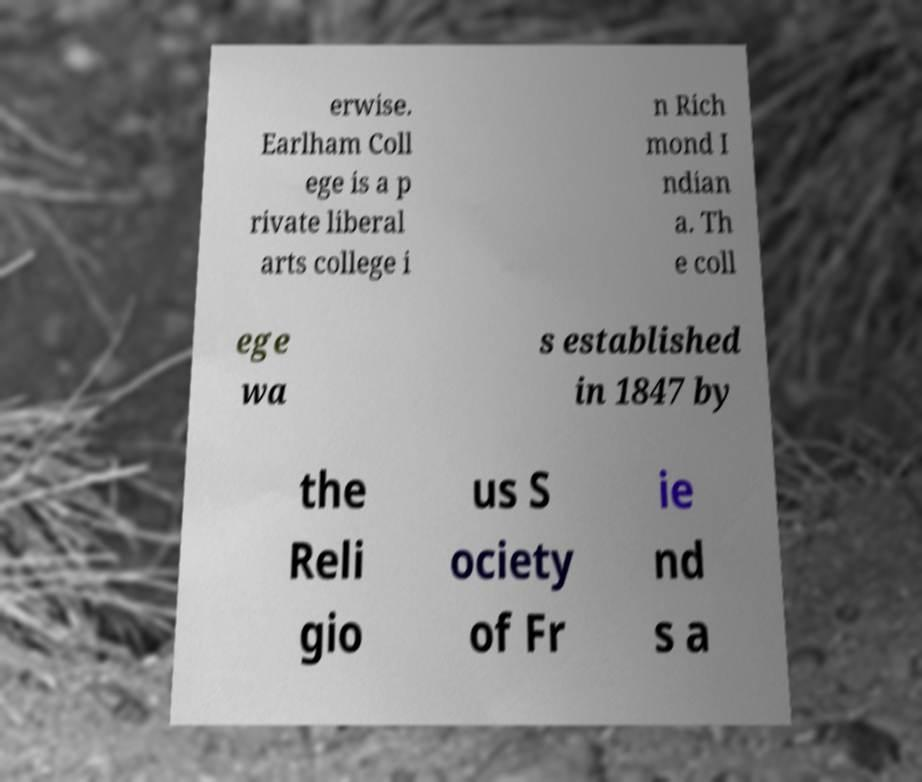I need the written content from this picture converted into text. Can you do that? erwise. Earlham Coll ege is a p rivate liberal arts college i n Rich mond I ndian a. Th e coll ege wa s established in 1847 by the Reli gio us S ociety of Fr ie nd s a 